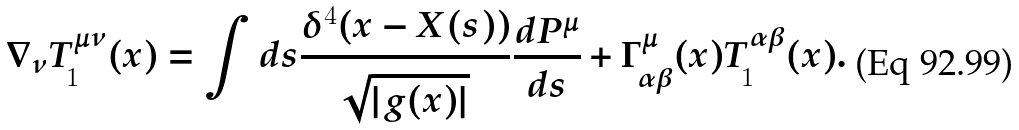<formula> <loc_0><loc_0><loc_500><loc_500>\nabla _ { \nu } T ^ { \mu \nu } _ { 1 } ( x ) = \int d s \frac { \delta ^ { 4 } ( x - X ( s ) ) } { \sqrt { | g ( x ) | } } \frac { d P ^ { \mu } } { d s } + \Gamma ^ { \mu } _ { \alpha \beta } ( x ) T ^ { \alpha \beta } _ { 1 } ( x ) .</formula> 